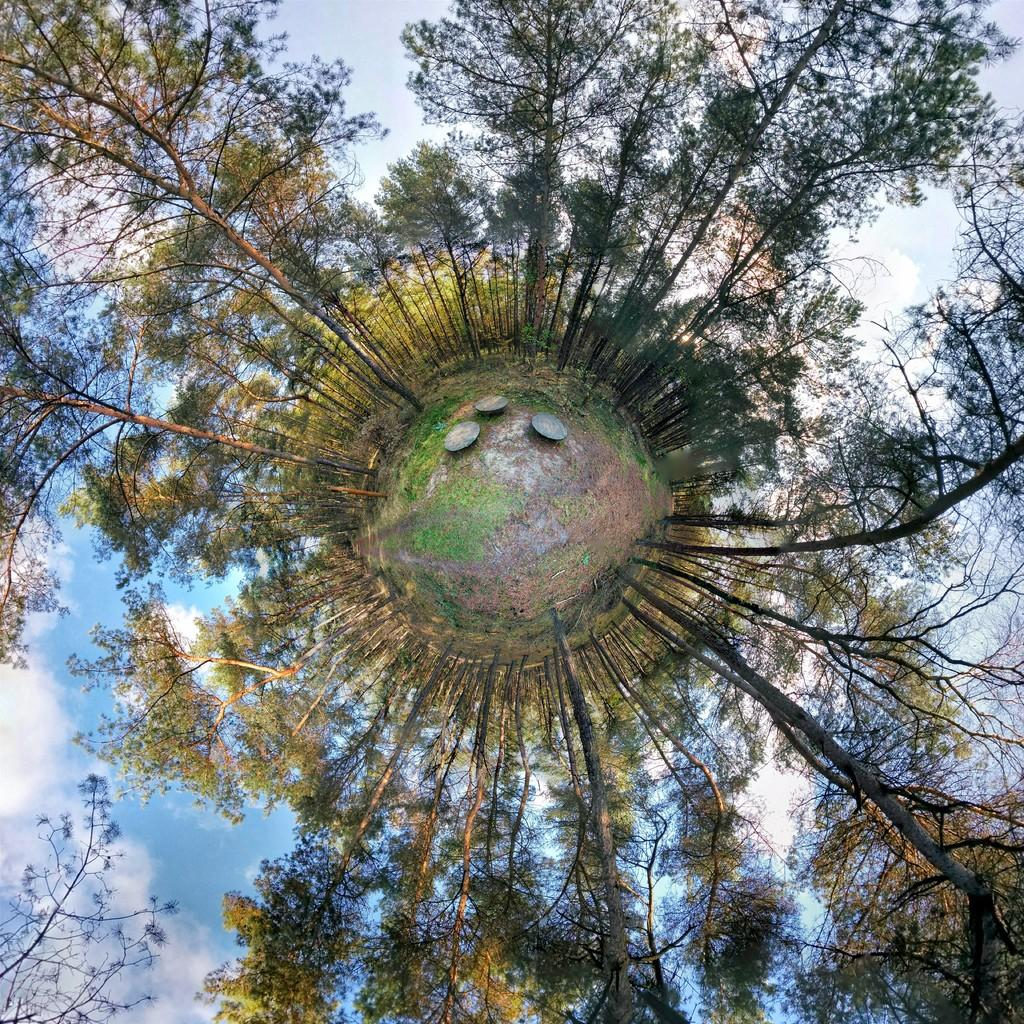What type of natural elements can be seen in the image? The image contains trees. What part of the natural environment is visible in the image? The sky is visible in the background of the image. How many objects are located in the middle of the image? There are three objects in the middle of the image. What type of activity is the copy performing in the image? There is no copy present in the image, so it is not possible to determine what activity the copy might be performing. 